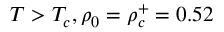<formula> <loc_0><loc_0><loc_500><loc_500>T > T _ { c } , \rho _ { 0 } = \rho _ { c } ^ { + } = 0 . 5 2</formula> 